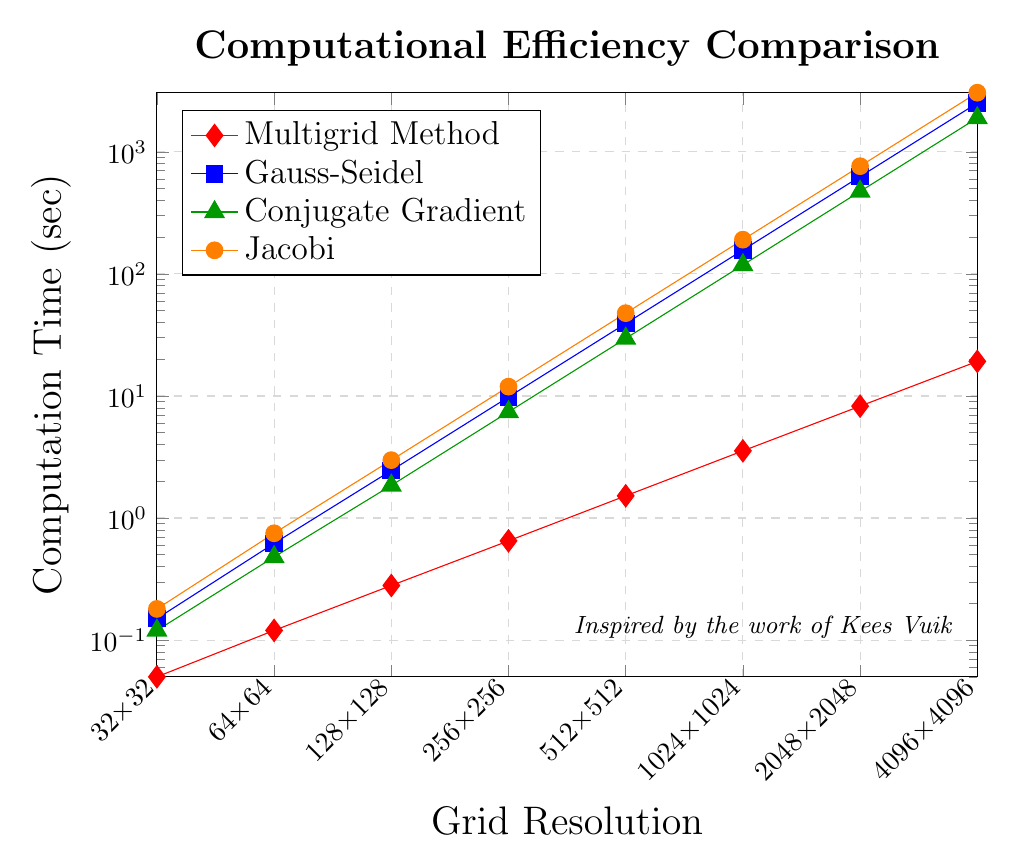What is the fastest solver for the 512x512 grid resolution? The lowest computation time for the 512x512 grid resolution is observed in the Multigrid Method. From the plot, all the other methods have higher computation times.
Answer: Multigrid Method By how much does the computation time increase for the Gauss-Seidel method when the grid resolution increases from 256x256 to 1024x1024? At 256x256, the computation time is 9.80 seconds, and at 1024x1024, it is 156.80 seconds for the Gauss-Seidel method. The difference is 156.80 - 9.80 = 147.00 seconds.
Answer: 147.00 seconds Which method shows the steepest increase in computation time as the grid resolution increases from 32x32 to 4096x4096? The Gauss-Seidel method shows the highest final computation time (2508.80 seconds) from an initial computation time of 0.15 seconds, indicating the steepest increase.
Answer: Gauss-Seidel Compare the computation time of the Multigrid Method at 2048x2048 grid resolution to the computation time of the Conjugate Gradient method at 1024x1024. Which one is faster? The computation time for the Multigrid Method at 2048x2048 is 8.25 seconds, while for the Conjugate Gradient method at 1024x1024, it is 118.40 seconds. The Multigrid Method is faster.
Answer: Multigrid Method What trend can you observe in the computation time for all methods as the grid resolution increases? All methods exhibit an increasing trend in computation time with increasing grid resolution. The rate of increase is faster for traditional methods (Gauss-Seidel, Conjugate Gradient, and Jacobi) compared to the Multigrid Method.
Answer: Increasing trend What is the approximate ratio of the computation time of the Multigrid Method to the Jacobi method for the 4096x4096 grid resolution? For the 4096x4096 grid resolution, the Multigrid Method takes 19.20 seconds, while the Jacobi method takes 3051.52 seconds. The ratio is approximately 19.20 / 3051.52 ≈ 0.0063.
Answer: 0.0063 At which grid resolution does the computation time for the Conjugate Gradient method first exceed 100 seconds? The computation time for the Conjugate Gradient method first exceeds 100 seconds at the 1024x1024 grid resolution, where it is 118.40 seconds.
Answer: 1024x1024 How much faster is the Multigrid Method compared to the Gauss-Seidel method for the 128x128 grid resolution? The computation time for the Multigrid Method at 128x128 is 0.28 seconds, and for the Gauss-Seidel method, it is 2.45 seconds. The difference is 2.45 - 0.28 = 2.17 seconds.
Answer: 2.17 seconds What color represents the Multigrid Method in the plot, and why is it significant to identify the methods by color? The Multigrid Method is represented by the color red. Identifying the methods by color helps quickly differentiate between the multiple methods and compare their performance visually.
Answer: Red Which method has the lowest computation time across all grid resolutions and why might this be significant? The Multigrid Method consistently has the lowest computation time across all grid resolutions. This indicates its superior efficiency and scalability for increasing grid resolutions compared to traditional iterative solvers.
Answer: Multigrid Method 